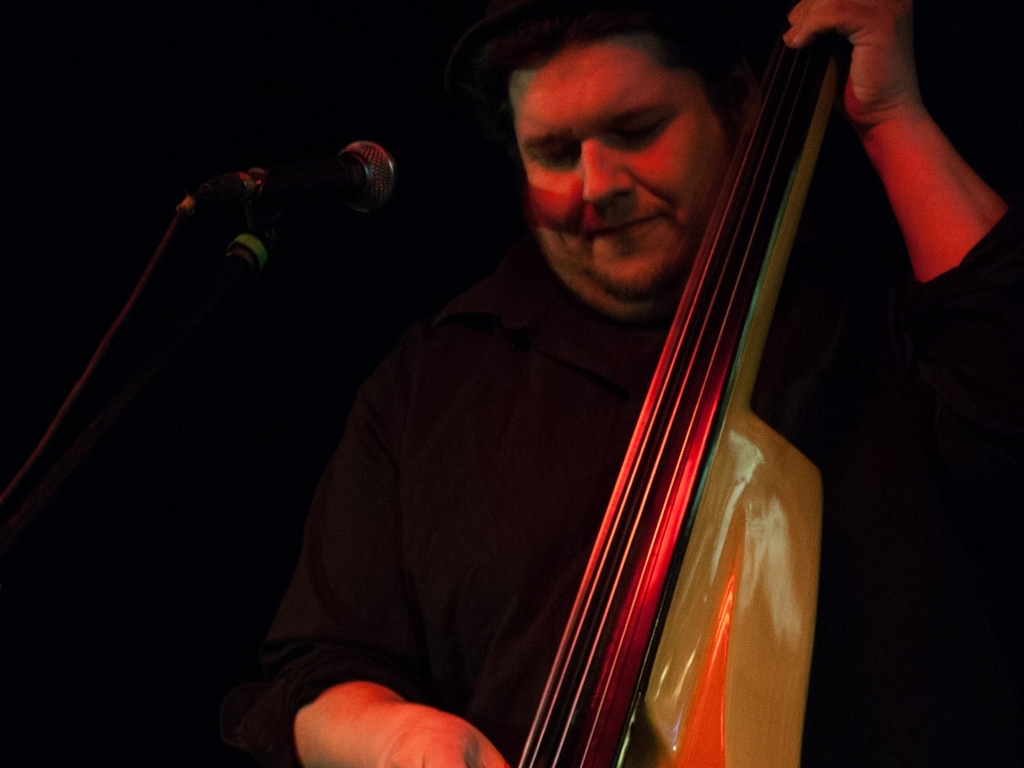What emotions does the person in the photograph seem to be expressing? The person depicted appears to be deeply immersed in their music, perhaps indicating a sense of concentration or even joy. The visible expression is one of focus and engagement, suggesting that the musician is emotionally connected to the performance. 